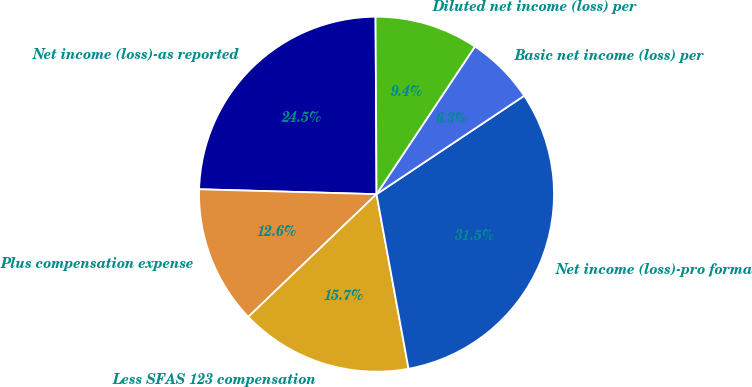Convert chart to OTSL. <chart><loc_0><loc_0><loc_500><loc_500><pie_chart><fcel>Net income (loss)-as reported<fcel>Plus compensation expense<fcel>Less SFAS 123 compensation<fcel>Net income (loss)-pro forma<fcel>Basic net income (loss) per<fcel>Diluted net income (loss) per<nl><fcel>24.47%<fcel>12.59%<fcel>15.74%<fcel>31.47%<fcel>6.29%<fcel>9.44%<nl></chart> 